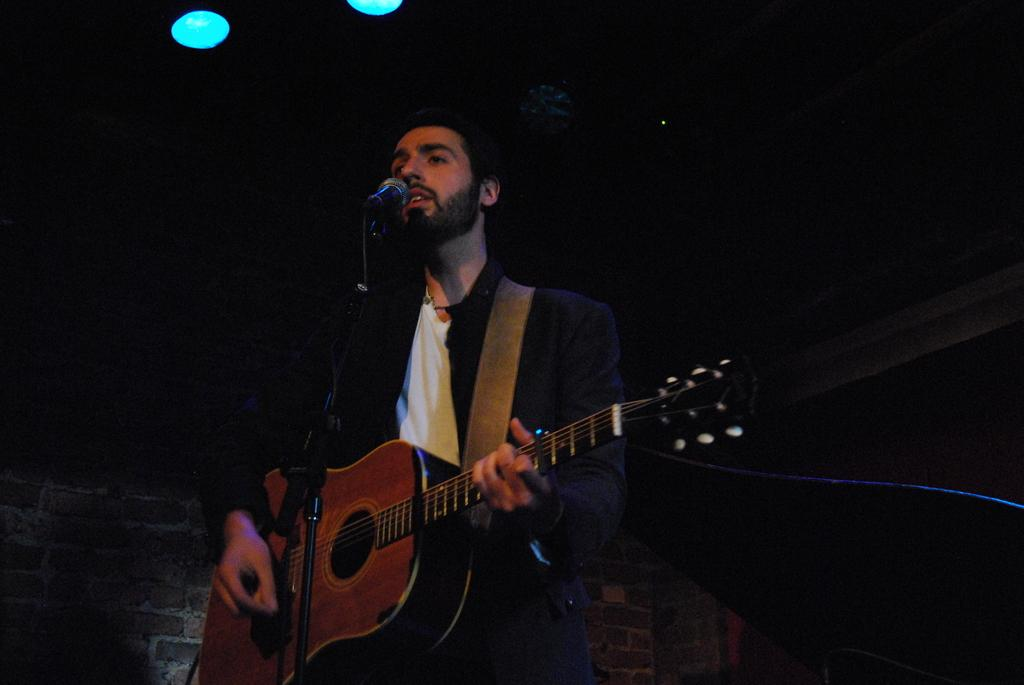What is the person in the image doing? The person is playing a guitar and singing. What is the person wearing? The person is wearing a black suit. What object is the person using to amplify their voice? There is a microphone in the image. How many geese are visible in the image? There are no geese present in the image. What type of nose does the person have in the image? The provided facts do not mention the person's nose, so we cannot determine the type of nose in the image. 